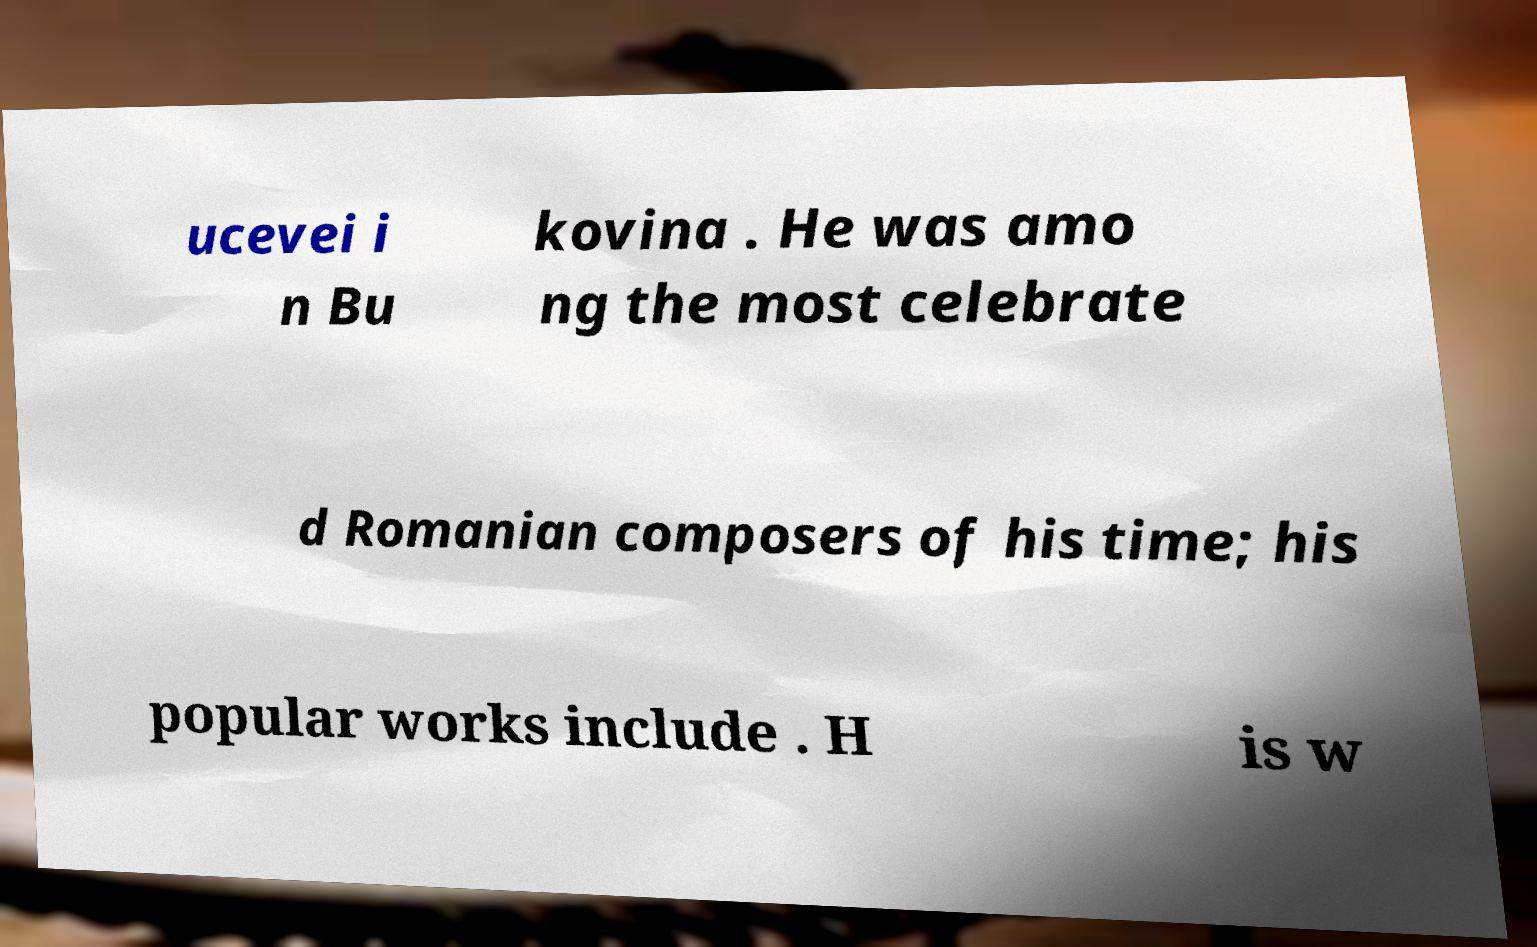Please read and relay the text visible in this image. What does it say? ucevei i n Bu kovina . He was amo ng the most celebrate d Romanian composers of his time; his popular works include . H is w 